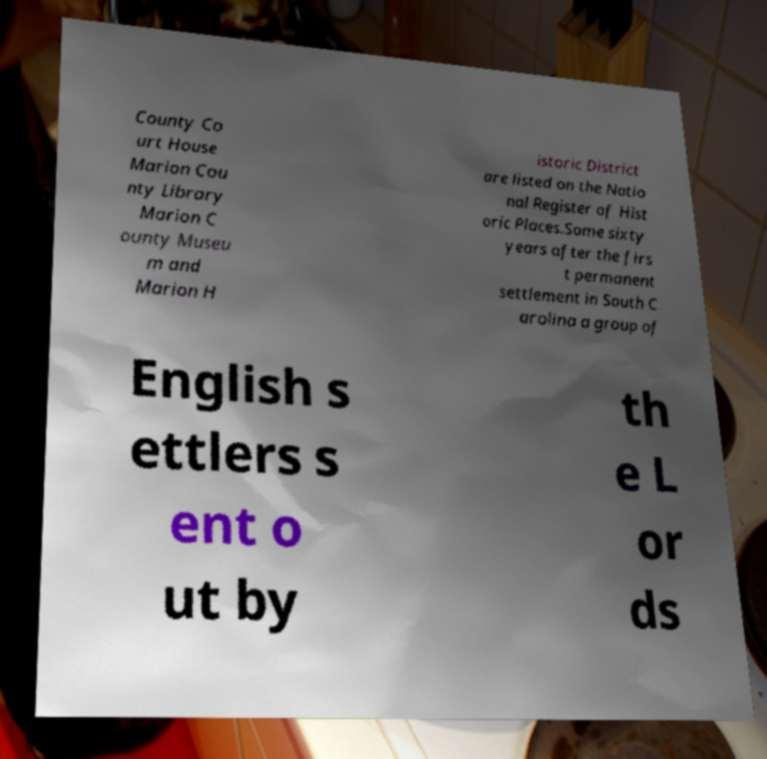Please identify and transcribe the text found in this image. County Co urt House Marion Cou nty Library Marion C ounty Museu m and Marion H istoric District are listed on the Natio nal Register of Hist oric Places.Some sixty years after the firs t permanent settlement in South C arolina a group of English s ettlers s ent o ut by th e L or ds 